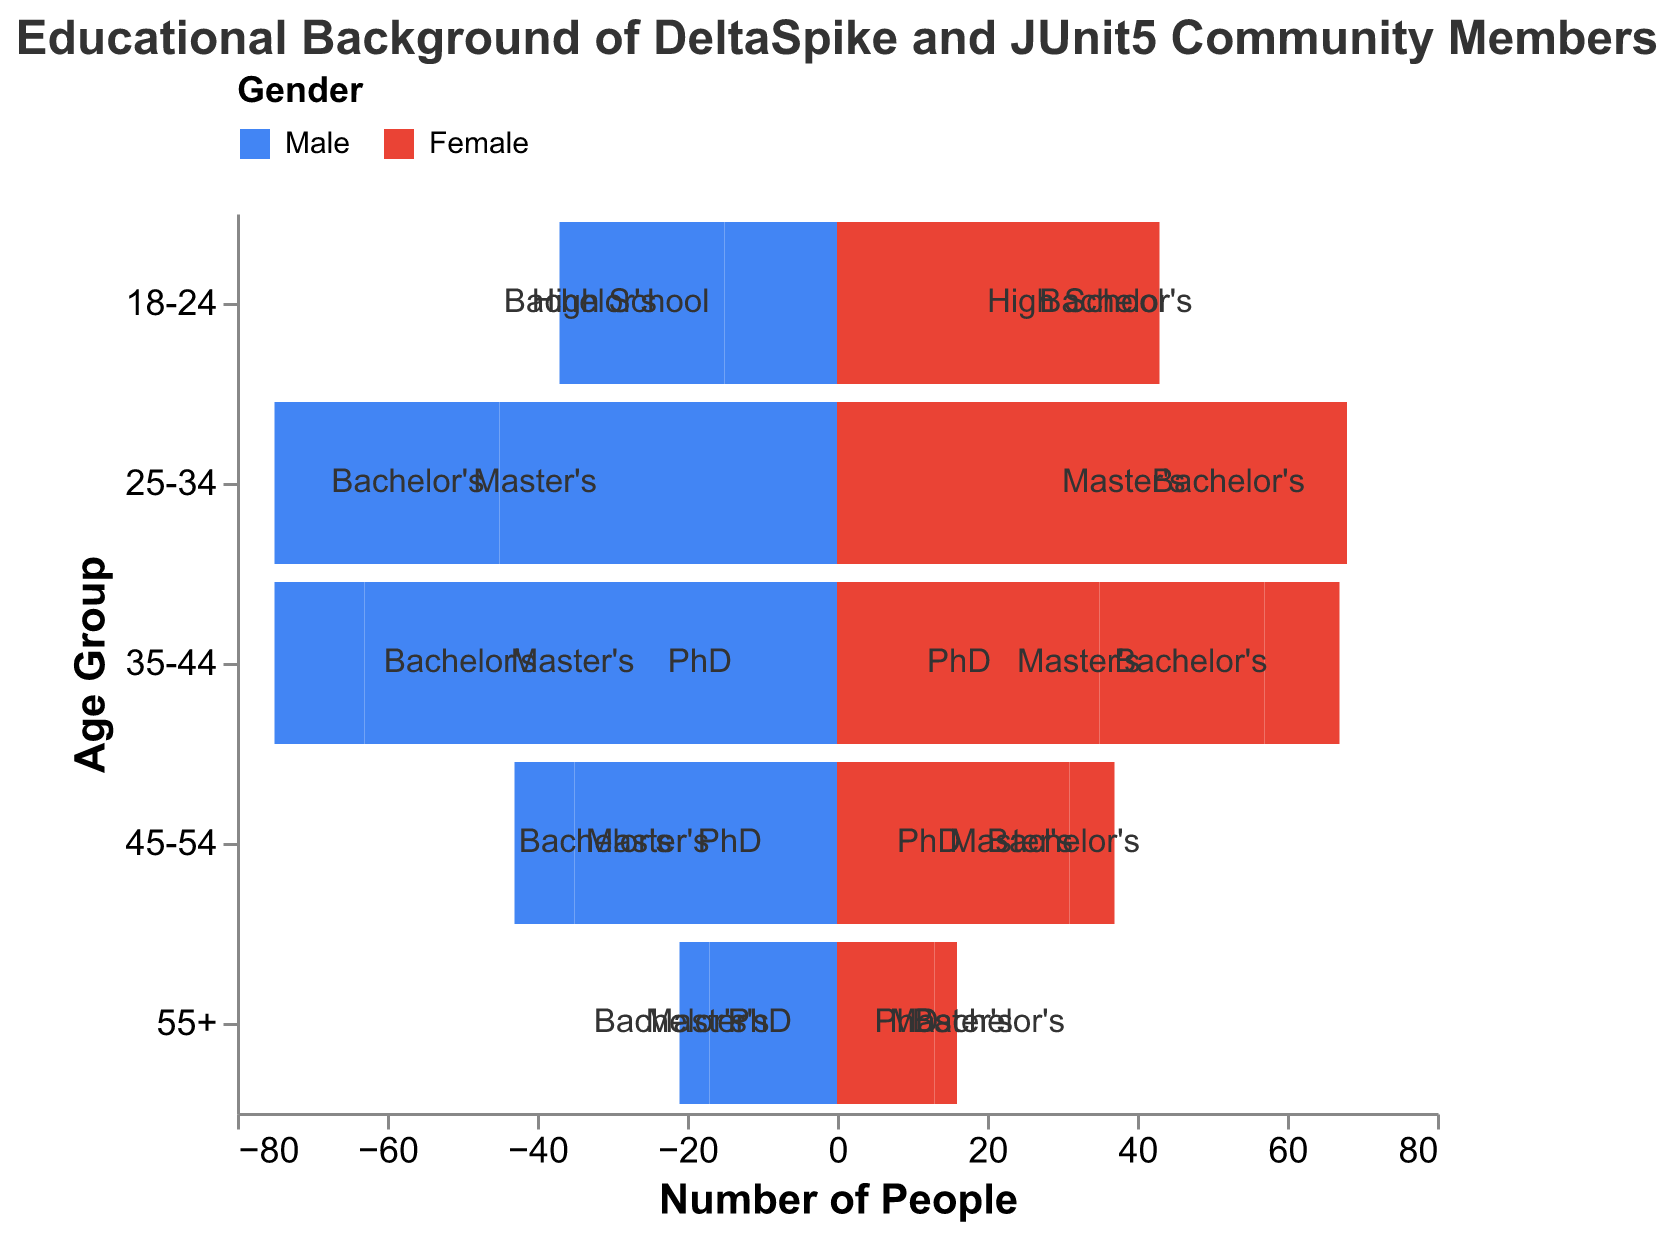Which age group has the highest number of Bachelor's degree holders? By observing the height of the bars labeled "Bachelor's" in each age group, the 25-34 age group has the highest total for both genders combined.
Answer: 25-34 What is the total number of males with a Master's degree in the 35-44 age group? Look at the bar for males with a Master's degree in the 35-44 age group and add the value, which is 25.
Answer: 25 Compare the number of females with a Bachelor's degree in the 18-24 age group to those in the 25-34 age group. Observe the length of the bars labeled "Bachelor's" for females in both age groups. The 18-24 group has 25 females, and the 25-34 group has 40 females.
Answer: 25 (18-24), 40 (25-34) Which degree type has more males in the 55+ age group, Master's or PhD? Compare the length of the bars for males with a Master's and PhD in the 55+ age group. Master's has 7, and PhD has 4.
Answer: Master's Which age group has the smallest number of PhD holders (both genders combined)? Add the values for males and females for PhD in each age group and identify the smallest sum. The 55+ group has 4 (males) + 3 (females) = 7, which is the smallest.
Answer: 55+ How many more Bachelor’s degree holders are there in the 25-34 age group compared to the 45-54 age group (both genders combined)? Sum the males and females in the 25-34 age group (45 + 40 = 85) and 45-54 age group (20 + 18 = 38), then subtract. 85 - 38 = 47
Answer: 47 What is the most common educational background in the 35-44 age group for both genders combined? Add up the counts for each degree type in the 35-44 age group: Bachelor's (38+35), Master's (25+22), PhD (12+10). Then compare the totals. Bachelor's has the highest count.
Answer: Bachelor's Which gender has more people with a high school degree in the 18-24 age group? Compare the lengths of the bars for high school graduates in the 18-24 age group for males and females. Females have 18, and males have 15.
Answer: Female Does the 45-54 age group have more female Master's degree holders or female PhD holders? Compare the lengths of the bars for females with Master's and PhD in the 45-54 age group. Master's has 13, and PhD has 6.
Answer: Master's 